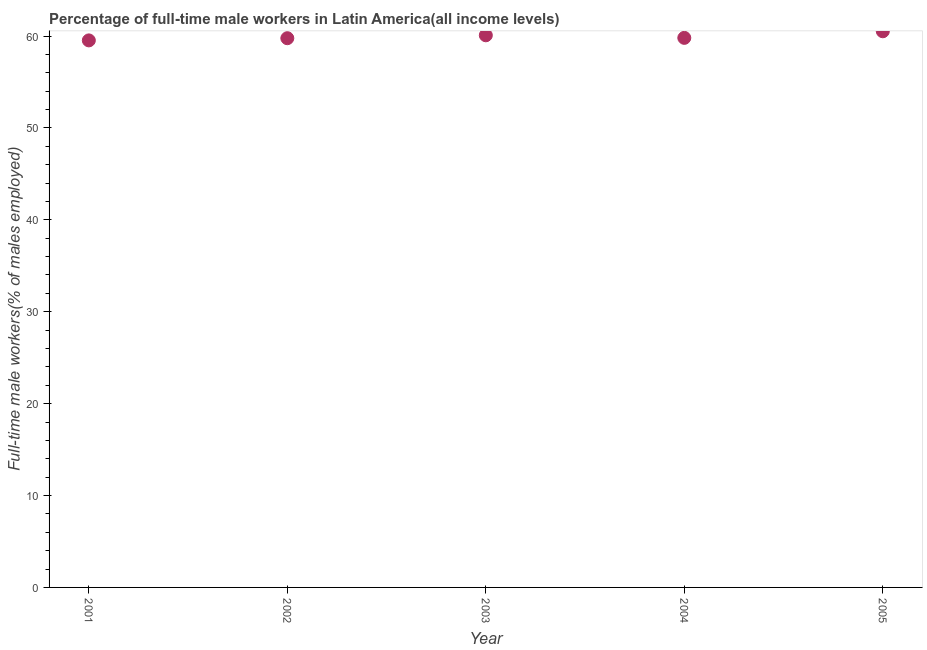What is the percentage of full-time male workers in 2003?
Offer a very short reply. 60.08. Across all years, what is the maximum percentage of full-time male workers?
Ensure brevity in your answer.  60.52. Across all years, what is the minimum percentage of full-time male workers?
Offer a very short reply. 59.52. What is the sum of the percentage of full-time male workers?
Your answer should be compact. 299.68. What is the difference between the percentage of full-time male workers in 2002 and 2004?
Provide a short and direct response. -0.04. What is the average percentage of full-time male workers per year?
Provide a succinct answer. 59.94. What is the median percentage of full-time male workers?
Provide a short and direct response. 59.8. Do a majority of the years between 2004 and 2003 (inclusive) have percentage of full-time male workers greater than 50 %?
Give a very brief answer. No. What is the ratio of the percentage of full-time male workers in 2001 to that in 2004?
Give a very brief answer. 1. Is the difference between the percentage of full-time male workers in 2001 and 2003 greater than the difference between any two years?
Ensure brevity in your answer.  No. What is the difference between the highest and the second highest percentage of full-time male workers?
Ensure brevity in your answer.  0.44. Is the sum of the percentage of full-time male workers in 2003 and 2004 greater than the maximum percentage of full-time male workers across all years?
Provide a short and direct response. Yes. What is the difference between the highest and the lowest percentage of full-time male workers?
Provide a succinct answer. 0.99. Does the percentage of full-time male workers monotonically increase over the years?
Offer a terse response. No. How many years are there in the graph?
Provide a short and direct response. 5. What is the difference between two consecutive major ticks on the Y-axis?
Ensure brevity in your answer.  10. Does the graph contain any zero values?
Ensure brevity in your answer.  No. Does the graph contain grids?
Give a very brief answer. No. What is the title of the graph?
Offer a terse response. Percentage of full-time male workers in Latin America(all income levels). What is the label or title of the X-axis?
Provide a short and direct response. Year. What is the label or title of the Y-axis?
Your response must be concise. Full-time male workers(% of males employed). What is the Full-time male workers(% of males employed) in 2001?
Provide a short and direct response. 59.52. What is the Full-time male workers(% of males employed) in 2002?
Offer a terse response. 59.76. What is the Full-time male workers(% of males employed) in 2003?
Provide a succinct answer. 60.08. What is the Full-time male workers(% of males employed) in 2004?
Give a very brief answer. 59.8. What is the Full-time male workers(% of males employed) in 2005?
Offer a very short reply. 60.52. What is the difference between the Full-time male workers(% of males employed) in 2001 and 2002?
Offer a very short reply. -0.24. What is the difference between the Full-time male workers(% of males employed) in 2001 and 2003?
Give a very brief answer. -0.55. What is the difference between the Full-time male workers(% of males employed) in 2001 and 2004?
Give a very brief answer. -0.27. What is the difference between the Full-time male workers(% of males employed) in 2001 and 2005?
Offer a very short reply. -0.99. What is the difference between the Full-time male workers(% of males employed) in 2002 and 2003?
Offer a very short reply. -0.32. What is the difference between the Full-time male workers(% of males employed) in 2002 and 2004?
Your answer should be very brief. -0.04. What is the difference between the Full-time male workers(% of males employed) in 2002 and 2005?
Offer a terse response. -0.75. What is the difference between the Full-time male workers(% of males employed) in 2003 and 2004?
Give a very brief answer. 0.28. What is the difference between the Full-time male workers(% of males employed) in 2003 and 2005?
Offer a terse response. -0.44. What is the difference between the Full-time male workers(% of males employed) in 2004 and 2005?
Ensure brevity in your answer.  -0.72. What is the ratio of the Full-time male workers(% of males employed) in 2001 to that in 2002?
Ensure brevity in your answer.  1. What is the ratio of the Full-time male workers(% of males employed) in 2003 to that in 2004?
Provide a short and direct response. 1. What is the ratio of the Full-time male workers(% of males employed) in 2004 to that in 2005?
Provide a succinct answer. 0.99. 